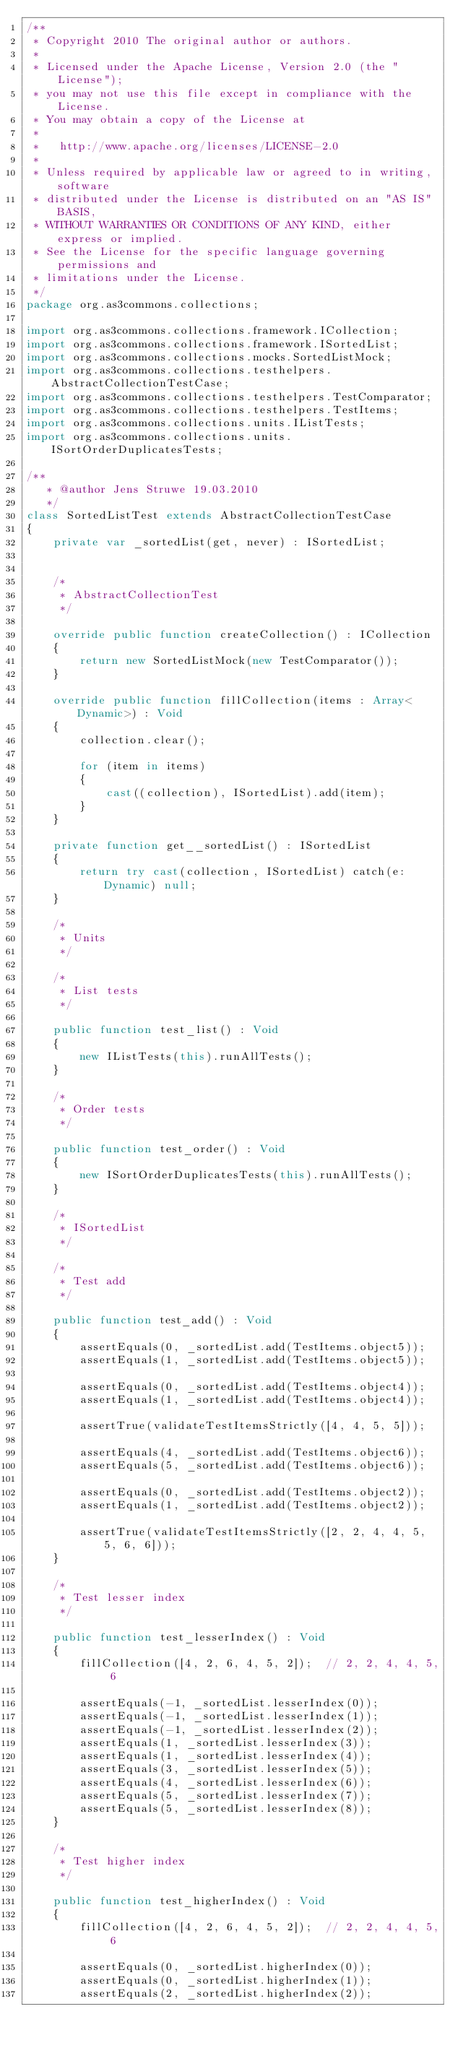<code> <loc_0><loc_0><loc_500><loc_500><_Haxe_>/**
 * Copyright 2010 The original author or authors.
 * 
 * Licensed under the Apache License, Version 2.0 (the "License");
 * you may not use this file except in compliance with the License.
 * You may obtain a copy of the License at
 * 
 *   http://www.apache.org/licenses/LICENSE-2.0
 * 
 * Unless required by applicable law or agreed to in writing, software
 * distributed under the License is distributed on an "AS IS" BASIS,
 * WITHOUT WARRANTIES OR CONDITIONS OF ANY KIND, either express or implied.
 * See the License for the specific language governing permissions and
 * limitations under the License.
 */
package org.as3commons.collections;

import org.as3commons.collections.framework.ICollection;
import org.as3commons.collections.framework.ISortedList;
import org.as3commons.collections.mocks.SortedListMock;
import org.as3commons.collections.testhelpers.AbstractCollectionTestCase;
import org.as3commons.collections.testhelpers.TestComparator;
import org.as3commons.collections.testhelpers.TestItems;
import org.as3commons.collections.units.IListTests;
import org.as3commons.collections.units.ISortOrderDuplicatesTests;

/**
	 * @author Jens Struwe 19.03.2010
	 */
class SortedListTest extends AbstractCollectionTestCase
{
    private var _sortedList(get, never) : ISortedList;

    
    /*
		 * AbstractCollectionTest
		 */
    
    override public function createCollection() : ICollection
    {
        return new SortedListMock(new TestComparator());
    }
    
    override public function fillCollection(items : Array<Dynamic>) : Void
    {
        collection.clear();
        
        for (item in items)
        {
            cast((collection), ISortedList).add(item);
        }
    }
    
    private function get__sortedList() : ISortedList
    {
        return try cast(collection, ISortedList) catch(e:Dynamic) null;
    }
    
    /*
		 * Units
		 */
    
    /*
		 * List tests
		 */
    
    public function test_list() : Void
    {
        new IListTests(this).runAllTests();
    }
    
    /*
		 * Order tests
		 */
    
    public function test_order() : Void
    {
        new ISortOrderDuplicatesTests(this).runAllTests();
    }
    
    /*
		 * ISortedList
		 */
    
    /*
		 * Test add
		 */
    
    public function test_add() : Void
    {
        assertEquals(0, _sortedList.add(TestItems.object5));
        assertEquals(1, _sortedList.add(TestItems.object5));
        
        assertEquals(0, _sortedList.add(TestItems.object4));
        assertEquals(1, _sortedList.add(TestItems.object4));
        
        assertTrue(validateTestItemsStrictly([4, 4, 5, 5]));
        
        assertEquals(4, _sortedList.add(TestItems.object6));
        assertEquals(5, _sortedList.add(TestItems.object6));
        
        assertEquals(0, _sortedList.add(TestItems.object2));
        assertEquals(1, _sortedList.add(TestItems.object2));
        
        assertTrue(validateTestItemsStrictly([2, 2, 4, 4, 5, 5, 6, 6]));
    }
    
    /*
		 * Test lesser index
		 */
    
    public function test_lesserIndex() : Void
    {
        fillCollection([4, 2, 6, 4, 5, 2]);  // 2, 2, 4, 4, 5, 6  
        
        assertEquals(-1, _sortedList.lesserIndex(0));
        assertEquals(-1, _sortedList.lesserIndex(1));
        assertEquals(-1, _sortedList.lesserIndex(2));
        assertEquals(1, _sortedList.lesserIndex(3));
        assertEquals(1, _sortedList.lesserIndex(4));
        assertEquals(3, _sortedList.lesserIndex(5));
        assertEquals(4, _sortedList.lesserIndex(6));
        assertEquals(5, _sortedList.lesserIndex(7));
        assertEquals(5, _sortedList.lesserIndex(8));
    }
    
    /*
		 * Test higher index
		 */
    
    public function test_higherIndex() : Void
    {
        fillCollection([4, 2, 6, 4, 5, 2]);  // 2, 2, 4, 4, 5, 6  
        
        assertEquals(0, _sortedList.higherIndex(0));
        assertEquals(0, _sortedList.higherIndex(1));
        assertEquals(2, _sortedList.higherIndex(2));</code> 